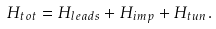Convert formula to latex. <formula><loc_0><loc_0><loc_500><loc_500>H _ { t o t } = H _ { l e a d s } + H _ { i m p } + H _ { t u n } .</formula> 